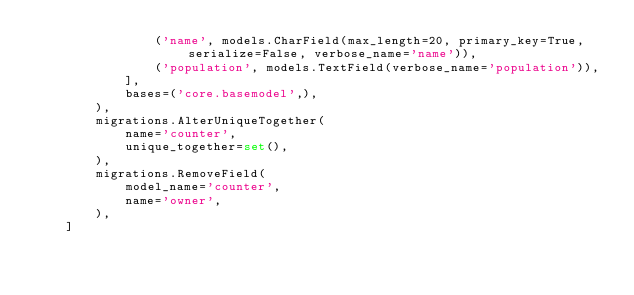<code> <loc_0><loc_0><loc_500><loc_500><_Python_>                ('name', models.CharField(max_length=20, primary_key=True, serialize=False, verbose_name='name')),
                ('population', models.TextField(verbose_name='population')),
            ],
            bases=('core.basemodel',),
        ),
        migrations.AlterUniqueTogether(
            name='counter',
            unique_together=set(),
        ),
        migrations.RemoveField(
            model_name='counter',
            name='owner',
        ),
    ]
</code> 